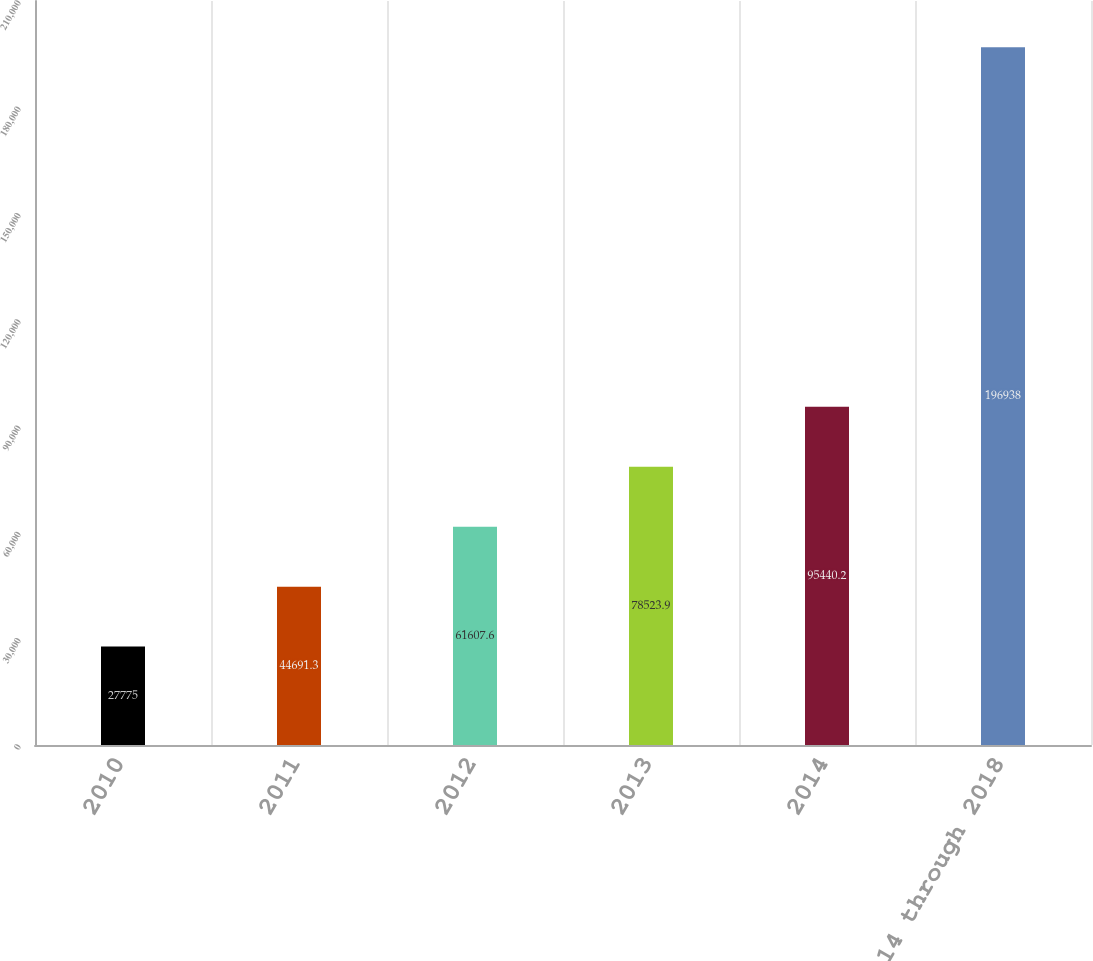Convert chart. <chart><loc_0><loc_0><loc_500><loc_500><bar_chart><fcel>2010<fcel>2011<fcel>2012<fcel>2013<fcel>2014<fcel>2014 through 2018<nl><fcel>27775<fcel>44691.3<fcel>61607.6<fcel>78523.9<fcel>95440.2<fcel>196938<nl></chart> 